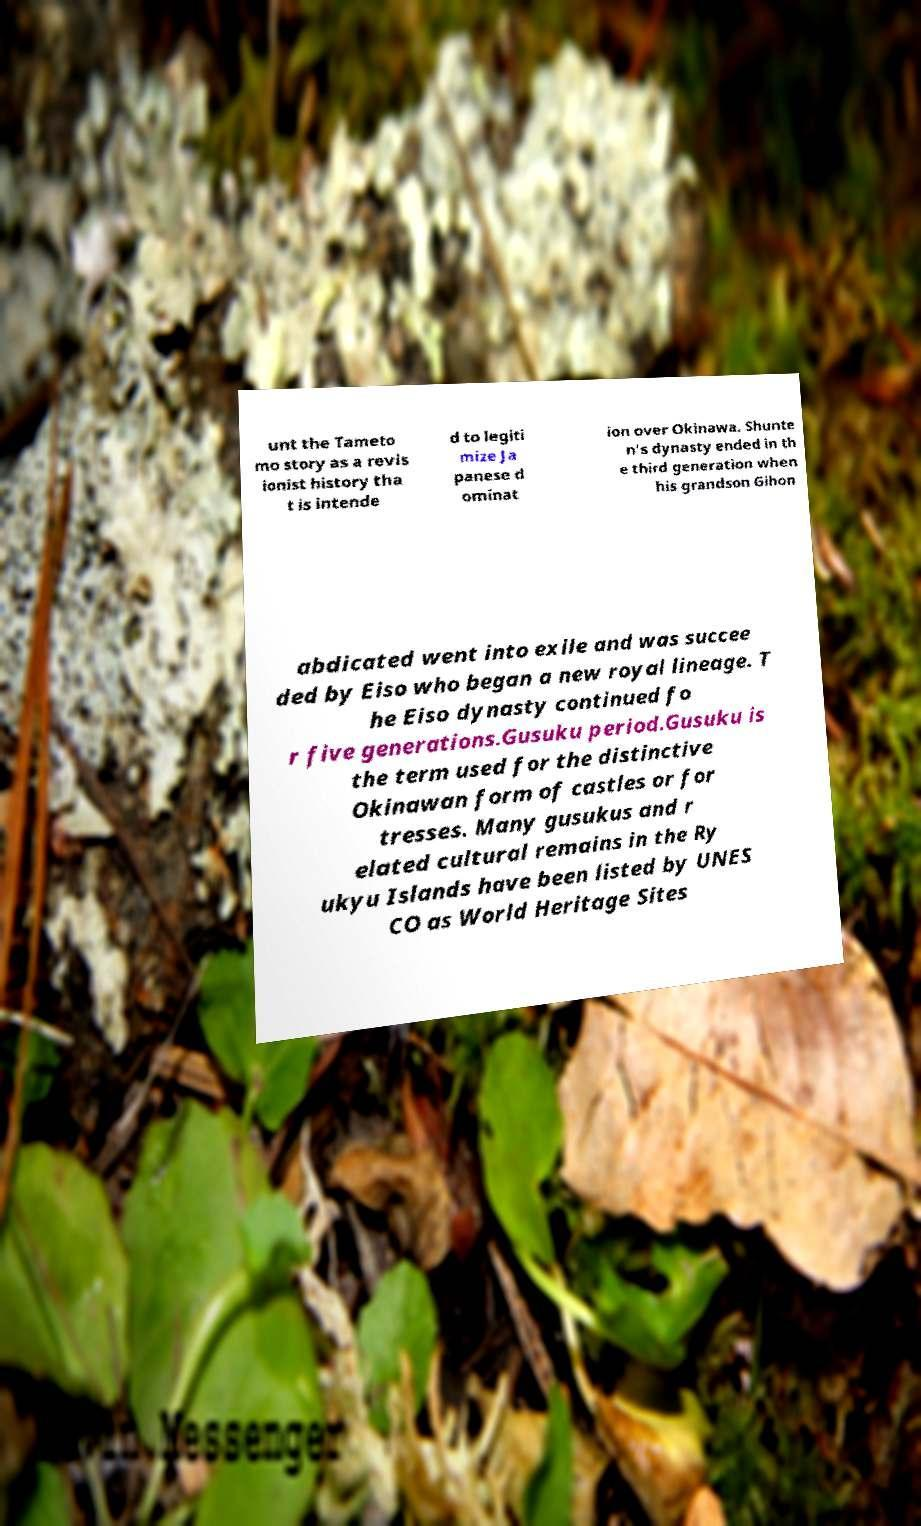Can you accurately transcribe the text from the provided image for me? unt the Tameto mo story as a revis ionist history tha t is intende d to legiti mize Ja panese d ominat ion over Okinawa. Shunte n's dynasty ended in th e third generation when his grandson Gihon abdicated went into exile and was succee ded by Eiso who began a new royal lineage. T he Eiso dynasty continued fo r five generations.Gusuku period.Gusuku is the term used for the distinctive Okinawan form of castles or for tresses. Many gusukus and r elated cultural remains in the Ry ukyu Islands have been listed by UNES CO as World Heritage Sites 